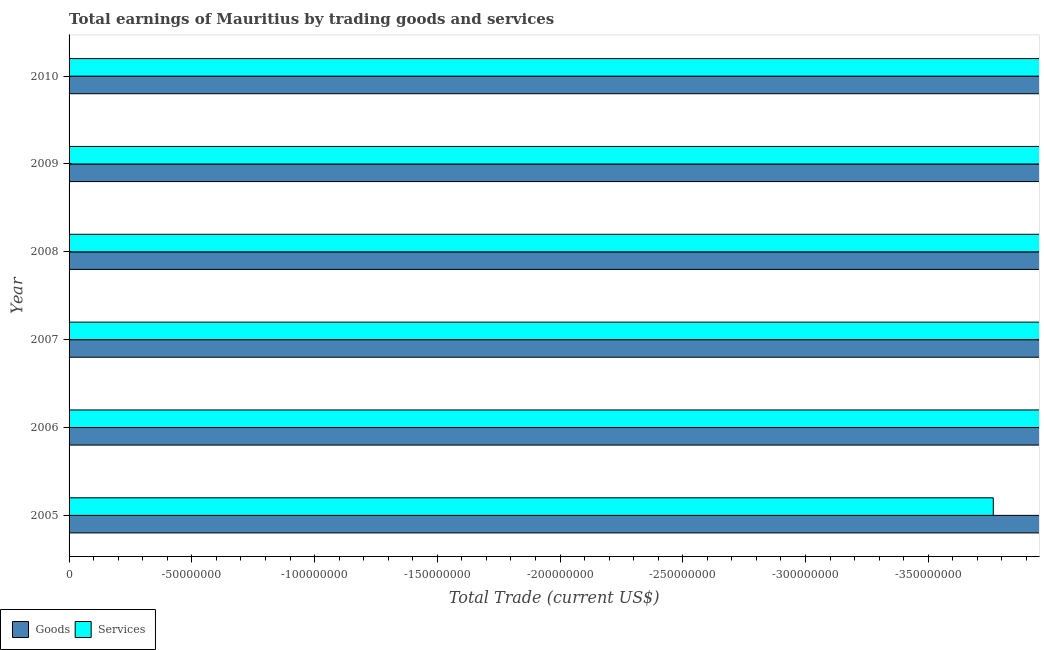How many different coloured bars are there?
Offer a very short reply. 0. Are the number of bars per tick equal to the number of legend labels?
Give a very brief answer. No. Are the number of bars on each tick of the Y-axis equal?
Your answer should be compact. Yes. How many bars are there on the 1st tick from the top?
Give a very brief answer. 0. In how many cases, is the number of bars for a given year not equal to the number of legend labels?
Offer a very short reply. 6. What is the amount earned by trading goods in 2008?
Your answer should be compact. 0. Across all years, what is the minimum amount earned by trading services?
Provide a succinct answer. 0. What is the difference between the amount earned by trading goods in 2006 and the amount earned by trading services in 2008?
Give a very brief answer. 0. What is the average amount earned by trading goods per year?
Give a very brief answer. 0. In how many years, is the amount earned by trading services greater than -320000000 US$?
Your answer should be very brief. 0. How many years are there in the graph?
Offer a terse response. 6. What is the difference between two consecutive major ticks on the X-axis?
Your answer should be very brief. 5.00e+07. Are the values on the major ticks of X-axis written in scientific E-notation?
Keep it short and to the point. No. Where does the legend appear in the graph?
Provide a short and direct response. Bottom left. How many legend labels are there?
Provide a short and direct response. 2. What is the title of the graph?
Offer a very short reply. Total earnings of Mauritius by trading goods and services. What is the label or title of the X-axis?
Your answer should be compact. Total Trade (current US$). What is the Total Trade (current US$) of Goods in 2005?
Provide a short and direct response. 0. What is the Total Trade (current US$) in Services in 2005?
Offer a terse response. 0. What is the Total Trade (current US$) in Goods in 2007?
Your answer should be compact. 0. What is the Total Trade (current US$) of Services in 2007?
Your answer should be very brief. 0. What is the Total Trade (current US$) in Goods in 2008?
Provide a succinct answer. 0. What is the Total Trade (current US$) in Services in 2008?
Offer a very short reply. 0. What is the Total Trade (current US$) of Goods in 2009?
Your answer should be compact. 0. What is the Total Trade (current US$) of Services in 2009?
Your answer should be compact. 0. What is the Total Trade (current US$) in Goods in 2010?
Your answer should be very brief. 0. What is the total Total Trade (current US$) in Goods in the graph?
Provide a short and direct response. 0. What is the total Total Trade (current US$) of Services in the graph?
Offer a terse response. 0. What is the average Total Trade (current US$) in Services per year?
Give a very brief answer. 0. 